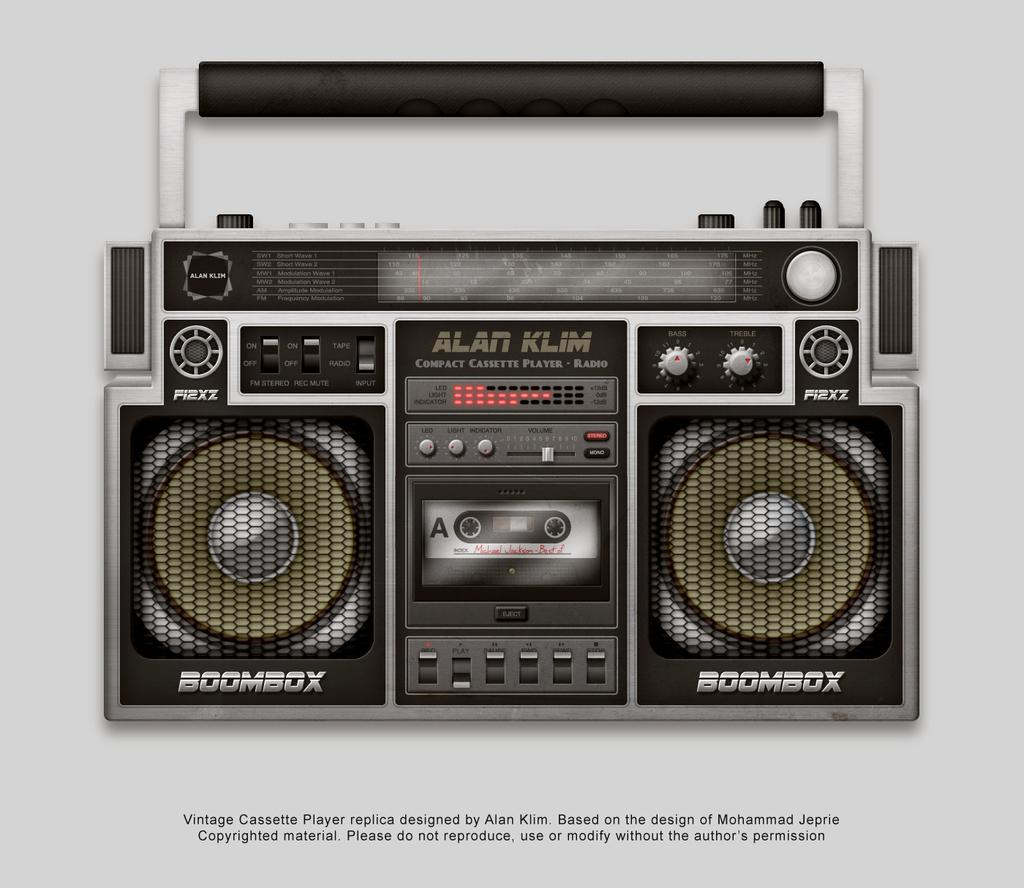What type of device is visible in the image? There is an old tape recorder in the image. What are the two objects that accompany the tape recorder? There are two speakers in the image. What is being used with the tape recorder? There is a cassette in the image. What feature of the tape recorder allows for easy transportation? The tape recorder has a handle. How can the tape recorder be controlled? The tape recorder has buttons. What can be seen in the image besides the devices? There is some text in the image. What color is the background of the image? The background of the image is white. What type of behavior is exhibited by the yard in the image? There is no yard present in the image, so it is not possible to determine any behavior. 